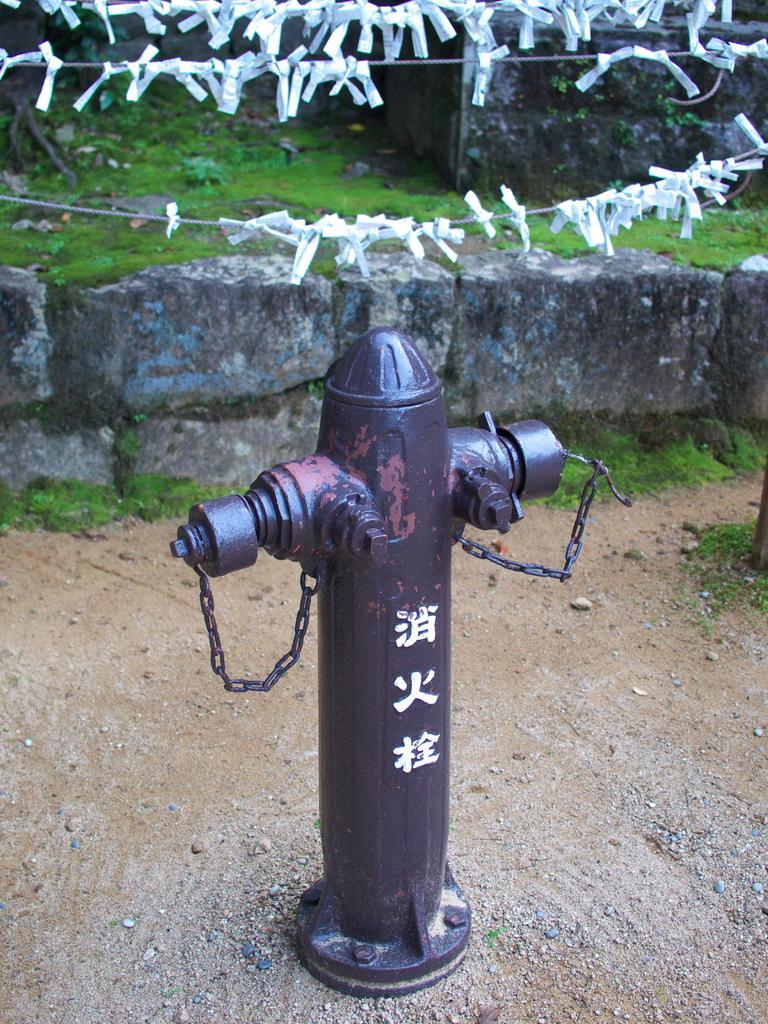Describe this image in one or two sentences. There is a pole having chains on the ground. Above this pole, there are decorative papers attached to the threads. In the background, there is wall and there's grass on the ground. 